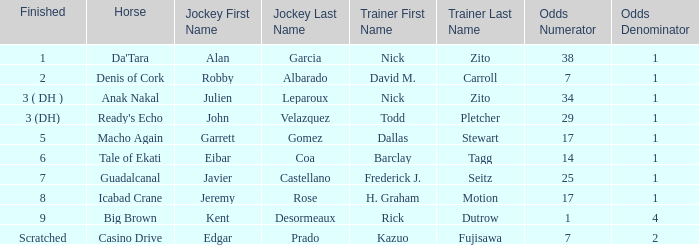Which horse completed in 8th place? Icabad Crane. 